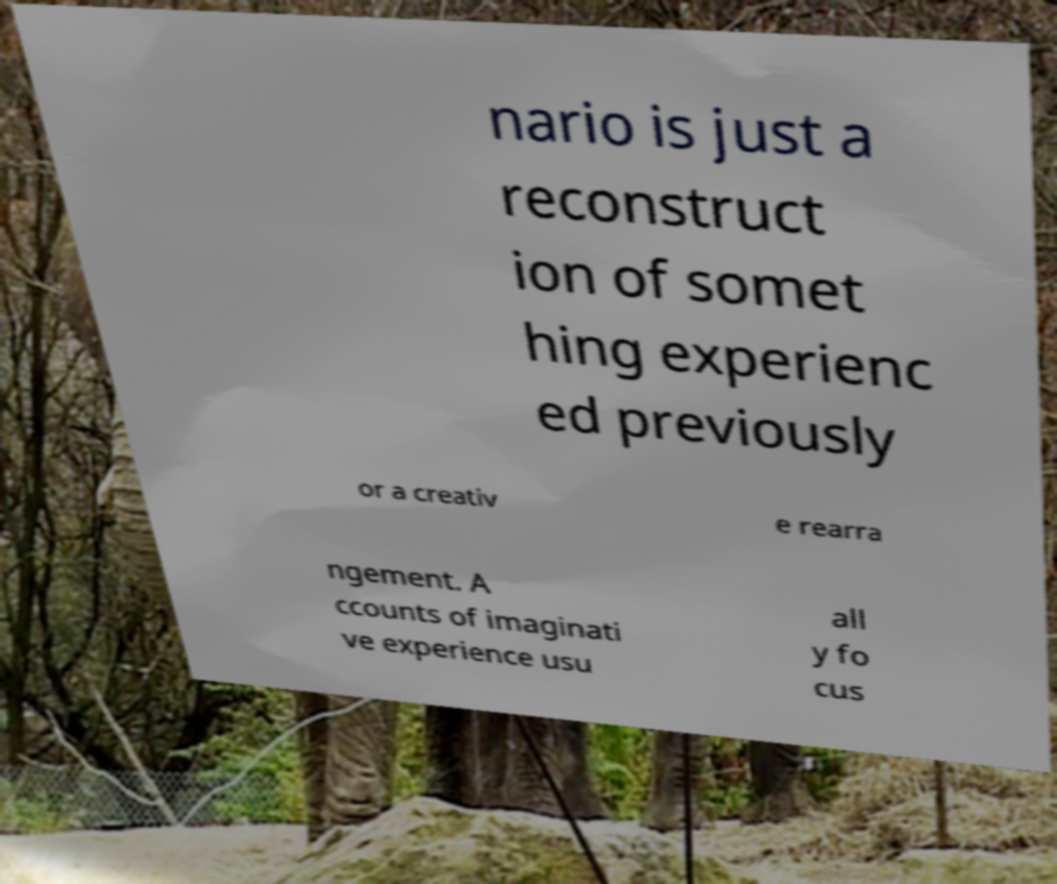Could you assist in decoding the text presented in this image and type it out clearly? nario is just a reconstruct ion of somet hing experienc ed previously or a creativ e rearra ngement. A ccounts of imaginati ve experience usu all y fo cus 